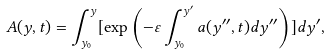Convert formula to latex. <formula><loc_0><loc_0><loc_500><loc_500>A ( y , t ) = \int _ { y _ { 0 } } ^ { y } [ \exp \left ( - \varepsilon \int _ { y _ { 0 } } ^ { y ^ { \prime } } a ( y ^ { \prime \prime } , t ) d y ^ { \prime \prime } \right ) ] d y ^ { \prime } ,</formula> 